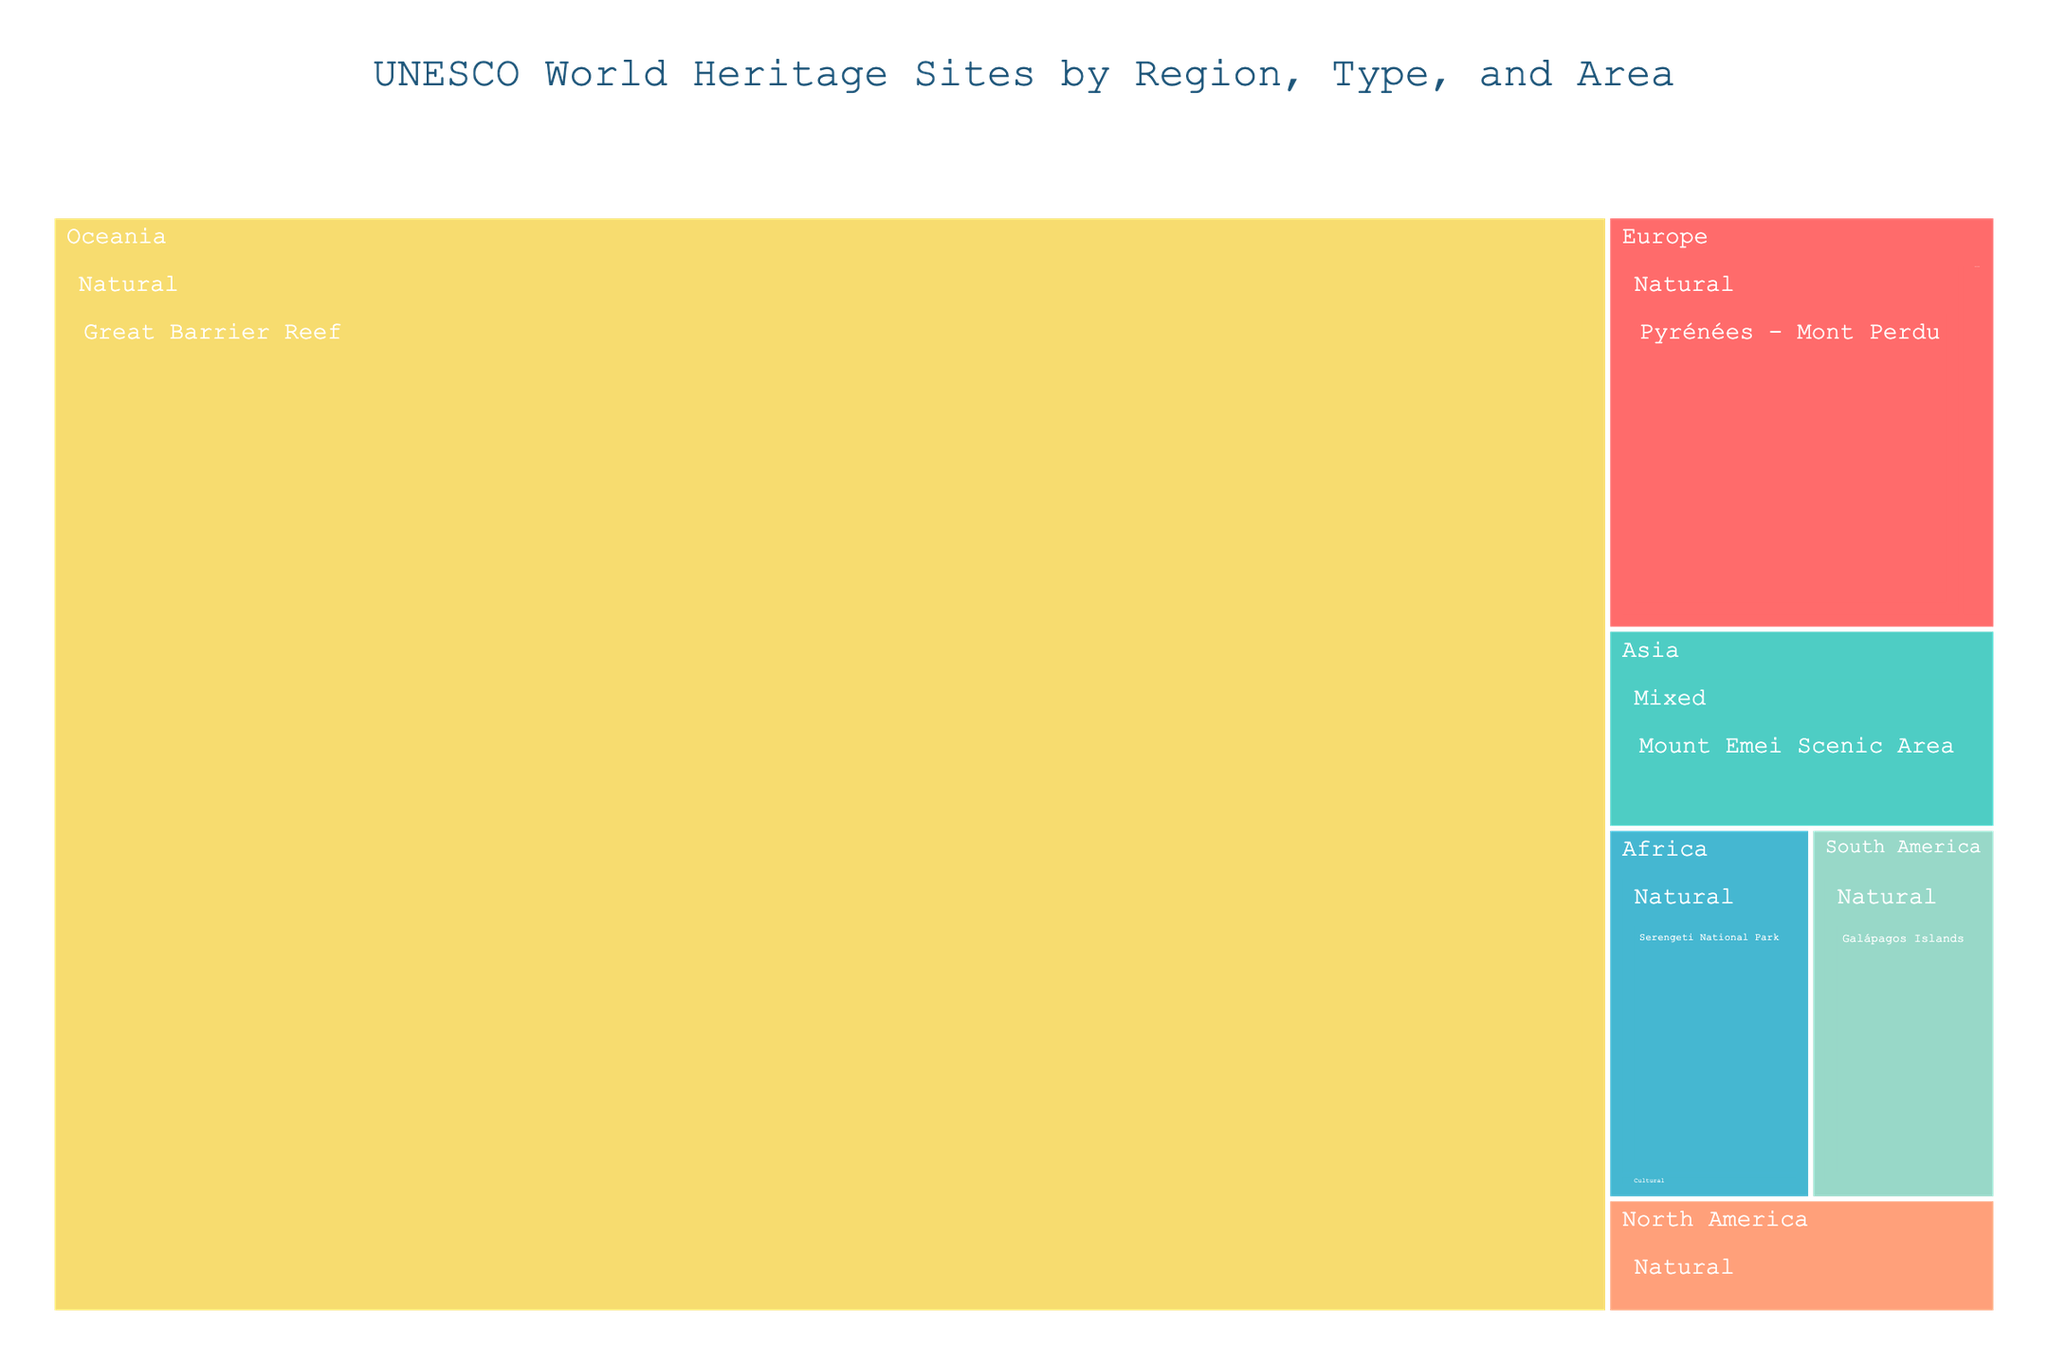What's the title of the Treemap? The title is usually positioned at the top of the plot and describes the content of the figure. In this case, it is "UNESCO World Heritage Sites by Region, Type, and Area".
Answer: UNESCO World Heritage Sites by Region, Type, and Area Which region has the site with the largest area? To determine this, look at the size of the rectangles in the Treemap. The largest rectangle represents the largest area. Comparing them, the "Great Barrier Reef" in Oceania is the largest.
Answer: Oceania How many Natural sites are there in the Treemap? To find this, count the number of rectangles colored by the regions and identified as "Natural" sites. There are six such sites: Pyrénées - Mont Perdu, Serengeti National Park, Yellowstone National Park, Galápagos Islands, and Great Barrier Reef.
Answer: 5 What is the combined area of all Cultural sites in Europe? Add the areas of the European sites classified as Cultural. Palace of Versailles (2000) + Historic Centre of Avignon (150).
Answer: 2150 km² Compare the area of the Statue of Liberty with the Medina of Marrakesh. Which is larger? Identify the areas of both sites: Statue of Liberty (59) and Medina of Marrakesh (600). Clearly, Medina of Marrakesh is larger.
Answer: Medina of Marrakesh Which site in Asia has the largest area, Cultural or Mixed? Examine the Cultural (Angkor, 400) and Mixed (Mount Emei Scenic Area, 15400) sites. The area of the Mixed site, Mount Emei Scenic Area, is larger.
Answer: Mixed What is the total number of regions represented in the Treemap? Count the distinct color categories denoted by the regions. There are six regions: Europe, Asia, Africa, North America, South America, and Oceania.
Answer: 6 Which region has the smallest area Cultural site and what is its area? Look for the smallest rectangle within the Cultural type. The smallest one is the Sydney Opera House in Oceania with an area of 5.
Answer: Oceania, 5 Which has a larger total area of Natural sites, Africa or North America? Sum the area of Natural sites in each region. Africa: Serengeti National Park (14763). North America: Yellowstone National Park (8983). Africa's total is larger.
Answer: Africa What is the average area of the Natural sites in the Treemap? Sum the areas of all Natural sites and then divide by their number. Natural sites and their areas: Pyrénées - Mont Perdu (30639), Serengeti National Park (14763), Yellowstone National Park (8983), Galápagos Islands (14000), Great Barrier Reef (348700). Total area: 353085, number of sites: 5, average area: 353085 / 5.
Answer: 70617 km² 